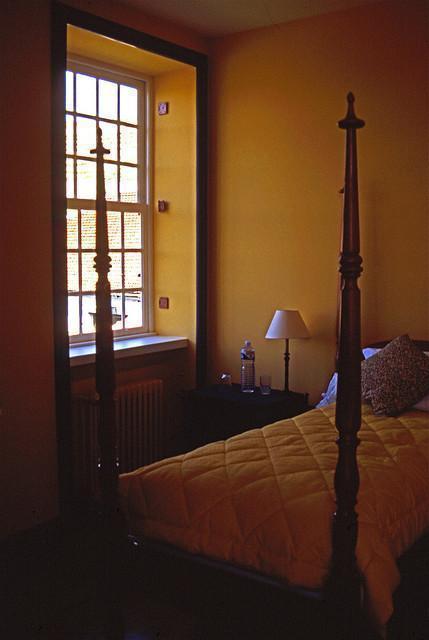What is the tip of the bed structures called?
Make your selection and explain in format: 'Answer: answer
Rationale: rationale.'
Options: Pillows, finials, mattress, headrest. Answer: finials.
Rationale: The only logical answer is the first based on the choices. 